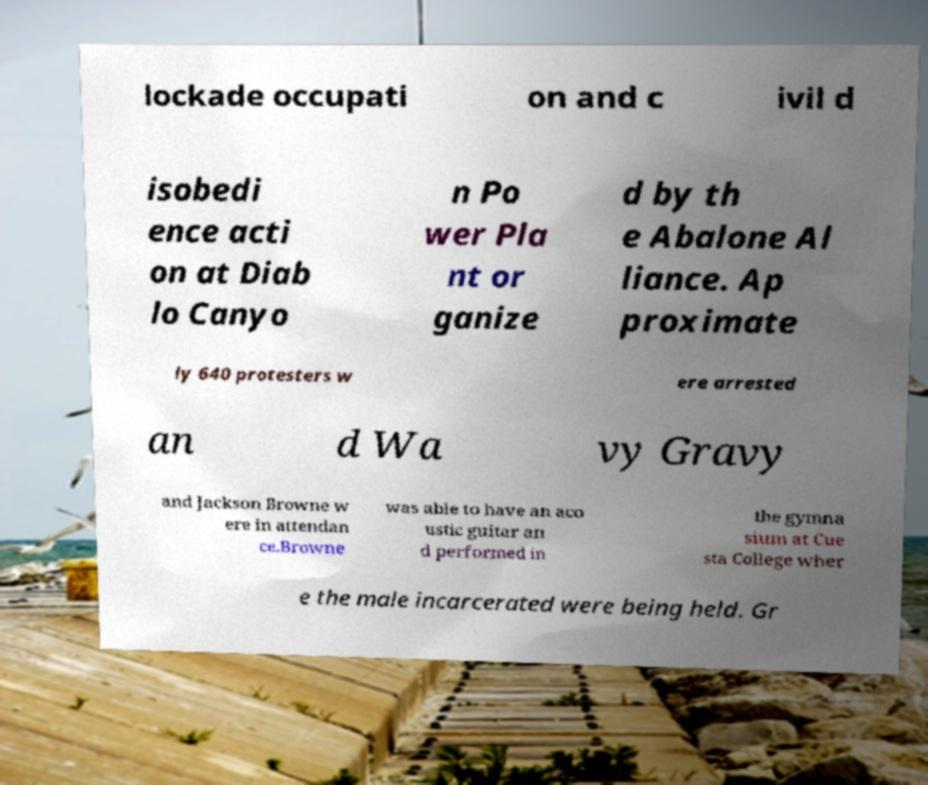Can you read and provide the text displayed in the image?This photo seems to have some interesting text. Can you extract and type it out for me? lockade occupati on and c ivil d isobedi ence acti on at Diab lo Canyo n Po wer Pla nt or ganize d by th e Abalone Al liance. Ap proximate ly 640 protesters w ere arrested an d Wa vy Gravy and Jackson Browne w ere in attendan ce.Browne was able to have an aco ustic guitar an d performed in the gymna sium at Cue sta College wher e the male incarcerated were being held. Gr 